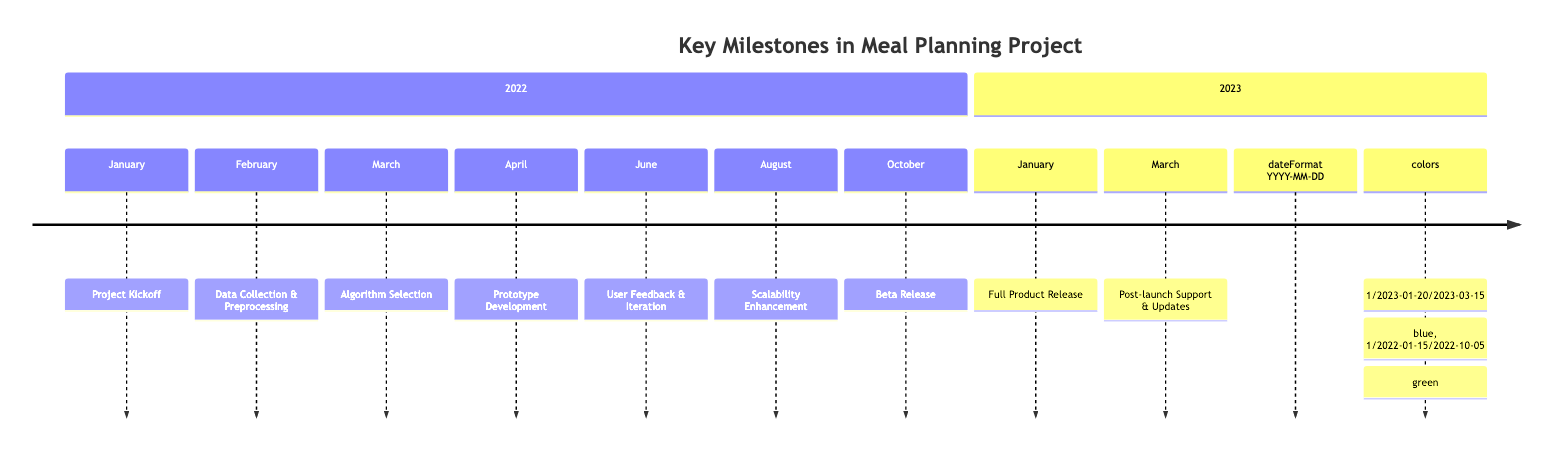What was the date of the Project Kickoff? The Project Kickoff occurred on January 15, 2022, as indicated in the timeline.
Answer: January 15, 2022 How many key milestones are there in total? The timeline includes a total of 9 key milestones from the start of the project through to post-launch support.
Answer: 9 What milestone is immediately after the Beta Release? Following the Beta Release on October 5, 2022, the next milestone is Full Product Release, which occurred on January 20, 2023.
Answer: Full Product Release Which milestone focuses on user feedback? The User Feedback & Iteration milestone emphasizes collecting user feedback and making iterative improvements and fixes.
Answer: User Feedback & Iteration In what month did the Scalability Enhancement occur? The Scalability Enhancement took place in August 2022, as specified in the timeline.
Answer: August What were some AI algorithms discussed during the Algorithm Selection? During the Algorithm Selection, some of the discussed AI algorithms were K-means clustering, collaborative filtering, and neural networks.
Answer: K-means clustering, collaborative filtering, neural networks How long after the Data Collection & Preprocessing did the Prototype Development start? Prototype Development started on April 12, 2022, which is 2 months after Data Collection & Preprocessing began on February 10, 2022.
Answer: 2 months What is a primary focus of the post-launch support? The primary focus of post-launch support includes continuous monitoring, user support, and implementing regular updates.
Answer: Continuous monitoring, user support, regular updates What color represents the milestones from January 2022 to October 2022? The milestones from January 2022 to October 2022 are represented in green in the timeline.
Answer: Green 